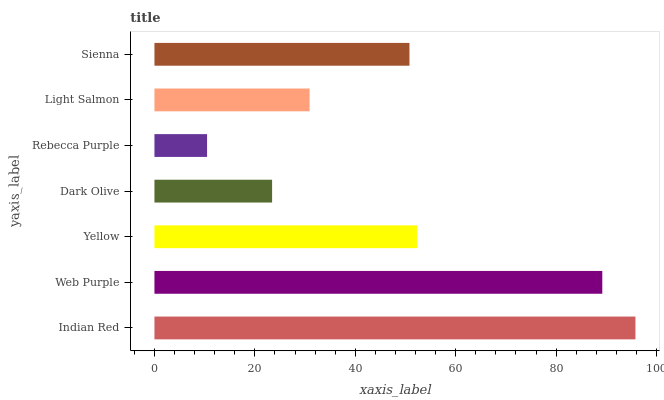Is Rebecca Purple the minimum?
Answer yes or no. Yes. Is Indian Red the maximum?
Answer yes or no. Yes. Is Web Purple the minimum?
Answer yes or no. No. Is Web Purple the maximum?
Answer yes or no. No. Is Indian Red greater than Web Purple?
Answer yes or no. Yes. Is Web Purple less than Indian Red?
Answer yes or no. Yes. Is Web Purple greater than Indian Red?
Answer yes or no. No. Is Indian Red less than Web Purple?
Answer yes or no. No. Is Sienna the high median?
Answer yes or no. Yes. Is Sienna the low median?
Answer yes or no. Yes. Is Rebecca Purple the high median?
Answer yes or no. No. Is Light Salmon the low median?
Answer yes or no. No. 